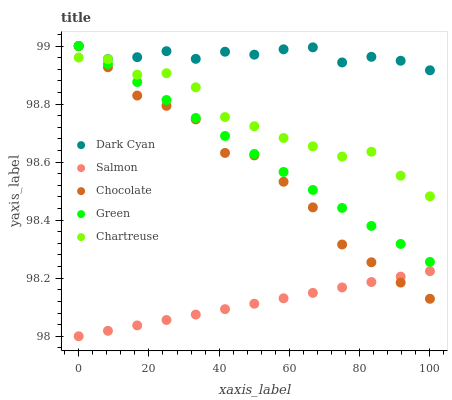Does Salmon have the minimum area under the curve?
Answer yes or no. Yes. Does Dark Cyan have the maximum area under the curve?
Answer yes or no. Yes. Does Green have the minimum area under the curve?
Answer yes or no. No. Does Green have the maximum area under the curve?
Answer yes or no. No. Is Green the smoothest?
Answer yes or no. Yes. Is Chocolate the roughest?
Answer yes or no. Yes. Is Chartreuse the smoothest?
Answer yes or no. No. Is Chartreuse the roughest?
Answer yes or no. No. Does Salmon have the lowest value?
Answer yes or no. Yes. Does Green have the lowest value?
Answer yes or no. No. Does Chocolate have the highest value?
Answer yes or no. Yes. Does Chartreuse have the highest value?
Answer yes or no. No. Is Chartreuse less than Dark Cyan?
Answer yes or no. Yes. Is Dark Cyan greater than Salmon?
Answer yes or no. Yes. Does Chartreuse intersect Chocolate?
Answer yes or no. Yes. Is Chartreuse less than Chocolate?
Answer yes or no. No. Is Chartreuse greater than Chocolate?
Answer yes or no. No. Does Chartreuse intersect Dark Cyan?
Answer yes or no. No. 